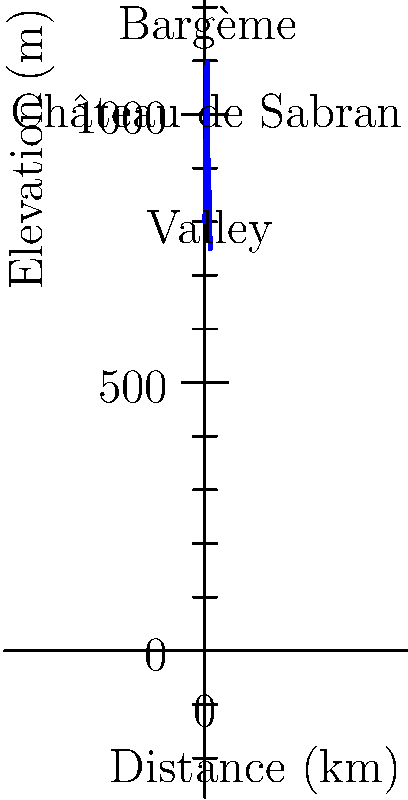Based on the topographic cross-section diagram, what is the approximate elevation difference between Bargème and the nearby valley to its east? To find the elevation difference between Bargème and the nearby valley to its east, we need to follow these steps:

1. Identify Bargème's elevation on the diagram:
   Bargème is clearly labeled at the highest point, with an elevation of 1097 meters.

2. Locate the valley to the east of Bargème:
   The valley is labeled to the right (east) of Bargème, at approximately 8 km on the distance axis.

3. Determine the valley's elevation:
   The valley's elevation is shown to be about 850 meters.

4. Calculate the elevation difference:
   Elevation difference = Bargème's elevation - Valley's elevation
   $$ 1097 \text{ m} - 850 \text{ m} = 247 \text{ m} $$

5. Round to an appropriate level of precision:
   Given the scale of the diagram, rounding to the nearest 10 meters is appropriate.

Therefore, the approximate elevation difference between Bargème and the nearby valley to its east is 250 meters.
Answer: 250 meters 